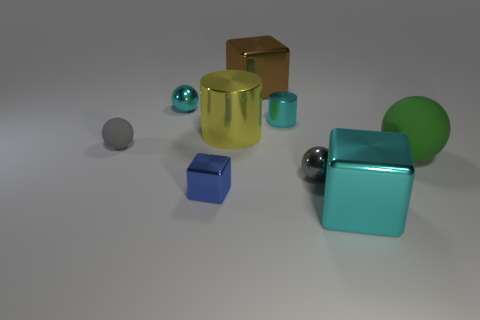Add 1 big cyan metal things. How many objects exist? 10 Subtract all blocks. How many objects are left? 6 Subtract all brown blocks. Subtract all metallic cubes. How many objects are left? 5 Add 8 small gray matte things. How many small gray matte things are left? 9 Add 4 big things. How many big things exist? 8 Subtract 0 gray cylinders. How many objects are left? 9 